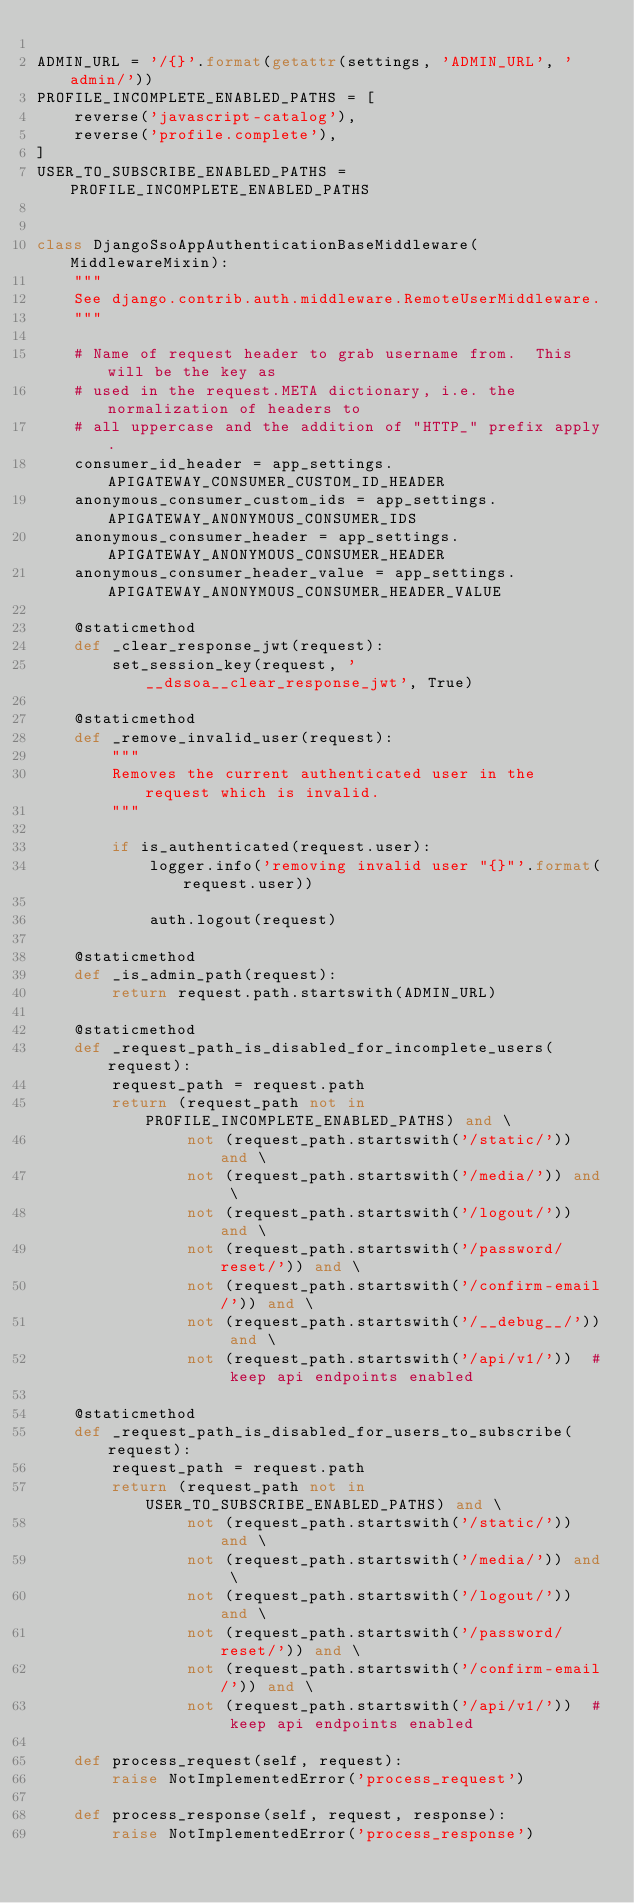Convert code to text. <code><loc_0><loc_0><loc_500><loc_500><_Python_>
ADMIN_URL = '/{}'.format(getattr(settings, 'ADMIN_URL', 'admin/'))
PROFILE_INCOMPLETE_ENABLED_PATHS = [
    reverse('javascript-catalog'),
    reverse('profile.complete'),
]
USER_TO_SUBSCRIBE_ENABLED_PATHS = PROFILE_INCOMPLETE_ENABLED_PATHS


class DjangoSsoAppAuthenticationBaseMiddleware(MiddlewareMixin):
    """
    See django.contrib.auth.middleware.RemoteUserMiddleware.
    """

    # Name of request header to grab username from.  This will be the key as
    # used in the request.META dictionary, i.e. the normalization of headers to
    # all uppercase and the addition of "HTTP_" prefix apply.
    consumer_id_header = app_settings.APIGATEWAY_CONSUMER_CUSTOM_ID_HEADER
    anonymous_consumer_custom_ids = app_settings.APIGATEWAY_ANONYMOUS_CONSUMER_IDS
    anonymous_consumer_header = app_settings.APIGATEWAY_ANONYMOUS_CONSUMER_HEADER
    anonymous_consumer_header_value = app_settings.APIGATEWAY_ANONYMOUS_CONSUMER_HEADER_VALUE

    @staticmethod
    def _clear_response_jwt(request):
        set_session_key(request, '__dssoa__clear_response_jwt', True)

    @staticmethod
    def _remove_invalid_user(request):
        """
        Removes the current authenticated user in the request which is invalid.
        """

        if is_authenticated(request.user):
            logger.info('removing invalid user "{}"'.format(request.user))

            auth.logout(request)

    @staticmethod
    def _is_admin_path(request):
        return request.path.startswith(ADMIN_URL)

    @staticmethod
    def _request_path_is_disabled_for_incomplete_users(request):
        request_path = request.path
        return (request_path not in PROFILE_INCOMPLETE_ENABLED_PATHS) and \
                not (request_path.startswith('/static/')) and \
                not (request_path.startswith('/media/')) and \
                not (request_path.startswith('/logout/')) and \
                not (request_path.startswith('/password/reset/')) and \
                not (request_path.startswith('/confirm-email/')) and \
                not (request_path.startswith('/__debug__/')) and \
                not (request_path.startswith('/api/v1/'))  # keep api endpoints enabled

    @staticmethod
    def _request_path_is_disabled_for_users_to_subscribe(request):
        request_path = request.path
        return (request_path not in USER_TO_SUBSCRIBE_ENABLED_PATHS) and \
                not (request_path.startswith('/static/')) and \
                not (request_path.startswith('/media/')) and \
                not (request_path.startswith('/logout/')) and \
                not (request_path.startswith('/password/reset/')) and \
                not (request_path.startswith('/confirm-email/')) and \
                not (request_path.startswith('/api/v1/'))  # keep api endpoints enabled

    def process_request(self, request):
        raise NotImplementedError('process_request')

    def process_response(self, request, response):
        raise NotImplementedError('process_response')
</code> 